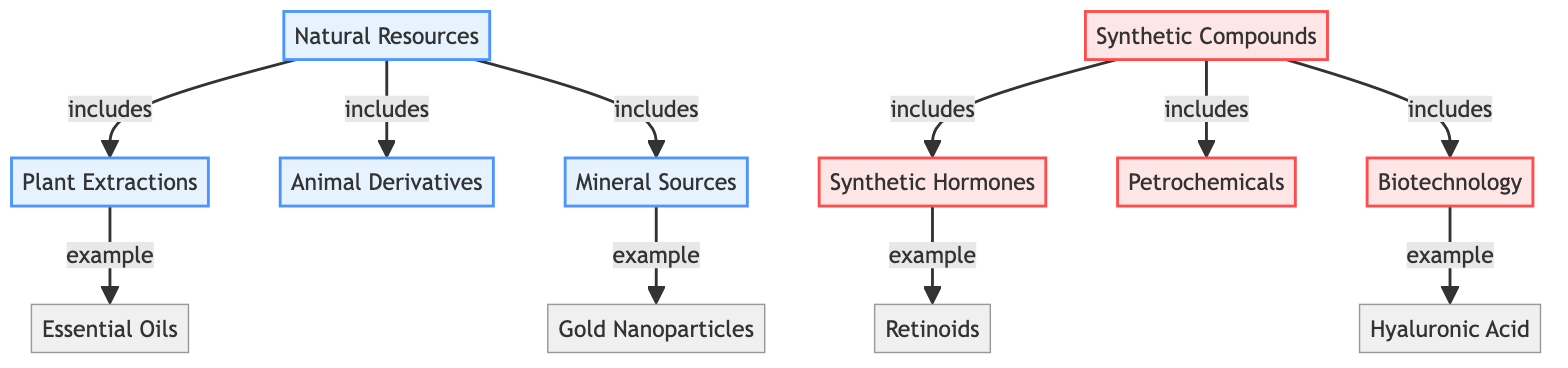What's the total number of natural resource categories in the diagram? The diagram lists three categories under natural resources: plant extractions, animal derivatives, and mineral sources. Therefore, the total is three.
Answer: 3 Which type of compounds is associated with hyaluronic acid? The diagram shows that hyaluronic acid is an example of biotechnology, which is part of synthetic compounds.
Answer: Biotechnology What is a direct example of mineral sources? According to the diagram, gold nanoparticles are specifically listed as an example under mineral sources.
Answer: Gold Nanoparticles Which two types of compounds are linked to synthetic hormones? The diagram indicates that synthetic hormones include retinoids. Therefore, the two types of compounds are synthetic hormones and retinoids.
Answer: Synthetic hormones and retinoids How many types of synthetic compounds are present in the diagram? The diagram presents three types of synthetic compounds: synthetic hormones, petrochemicals, and biotechnology, making the total three.
Answer: 3 What is the relationship between plant extractions and essential oils? The diagram shows that essential oils are an example that falls under the category of plant extractions, indicating a direct relationship.
Answer: Essential oils are an example Which category does retinoids belong to? The diagram categorizes retinoids as an example of synthetic hormones, which are under the broader category of synthetic compounds.
Answer: Synthetic hormones How many categories are mentioned under synthetic compounds? Reviewing the diagram reveals three distinct categories of synthetic compounds: synthetic hormones, petrochemicals, and biotechnology.
Answer: 3 What is a feature that distinguishes natural resources from synthetic compounds? The diagram visually differentiates natural resources, which include plant extractions, animal derivatives, and mineral sources, from synthetic compounds, which involve synthetic hormones, petrochemicals, and biotechnology.
Answer: Natural vs. Synthetic What are the examples given for synthetic compounds in the diagram? The diagram provides examples for synthetic compounds including retinoids, synthetic hormones, petrochemicals, and biotechnology, indicating multiple examples linked to that category.
Answer: Retinoids and others 